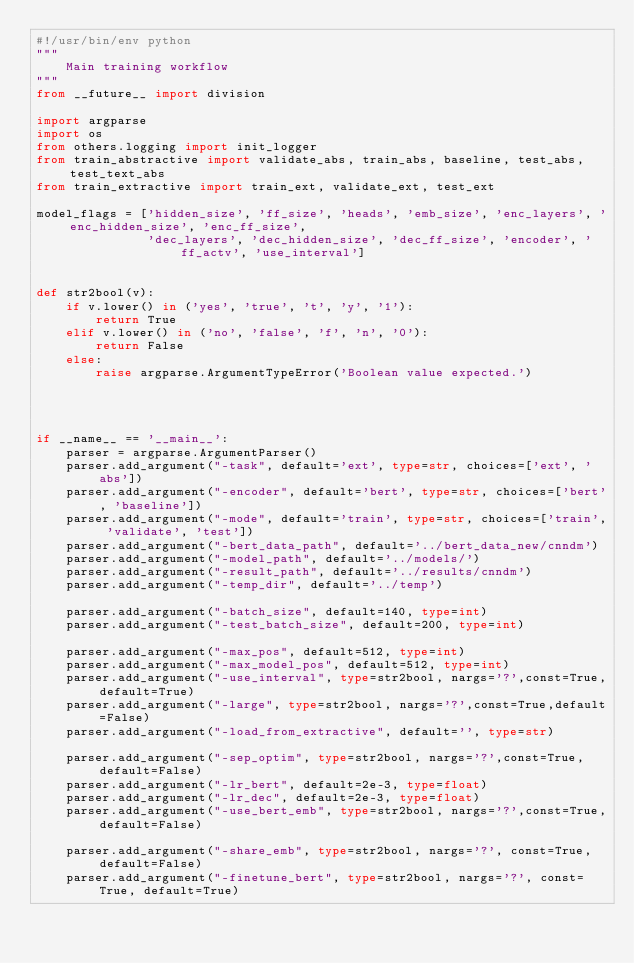Convert code to text. <code><loc_0><loc_0><loc_500><loc_500><_Python_>#!/usr/bin/env python
"""
    Main training workflow
"""
from __future__ import division

import argparse
import os
from others.logging import init_logger
from train_abstractive import validate_abs, train_abs, baseline, test_abs, test_text_abs
from train_extractive import train_ext, validate_ext, test_ext

model_flags = ['hidden_size', 'ff_size', 'heads', 'emb_size', 'enc_layers', 'enc_hidden_size', 'enc_ff_size',
               'dec_layers', 'dec_hidden_size', 'dec_ff_size', 'encoder', 'ff_actv', 'use_interval']


def str2bool(v):
    if v.lower() in ('yes', 'true', 't', 'y', '1'):
        return True
    elif v.lower() in ('no', 'false', 'f', 'n', '0'):
        return False
    else:
        raise argparse.ArgumentTypeError('Boolean value expected.')




if __name__ == '__main__':
    parser = argparse.ArgumentParser()
    parser.add_argument("-task", default='ext', type=str, choices=['ext', 'abs'])
    parser.add_argument("-encoder", default='bert', type=str, choices=['bert', 'baseline'])
    parser.add_argument("-mode", default='train', type=str, choices=['train', 'validate', 'test'])
    parser.add_argument("-bert_data_path", default='../bert_data_new/cnndm')
    parser.add_argument("-model_path", default='../models/')
    parser.add_argument("-result_path", default='../results/cnndm')
    parser.add_argument("-temp_dir", default='../temp')

    parser.add_argument("-batch_size", default=140, type=int)
    parser.add_argument("-test_batch_size", default=200, type=int)

    parser.add_argument("-max_pos", default=512, type=int)
    parser.add_argument("-max_model_pos", default=512, type=int)
    parser.add_argument("-use_interval", type=str2bool, nargs='?',const=True,default=True)
    parser.add_argument("-large", type=str2bool, nargs='?',const=True,default=False)
    parser.add_argument("-load_from_extractive", default='', type=str)

    parser.add_argument("-sep_optim", type=str2bool, nargs='?',const=True,default=False)
    parser.add_argument("-lr_bert", default=2e-3, type=float)
    parser.add_argument("-lr_dec", default=2e-3, type=float)
    parser.add_argument("-use_bert_emb", type=str2bool, nargs='?',const=True,default=False)

    parser.add_argument("-share_emb", type=str2bool, nargs='?', const=True, default=False)
    parser.add_argument("-finetune_bert", type=str2bool, nargs='?', const=True, default=True)</code> 